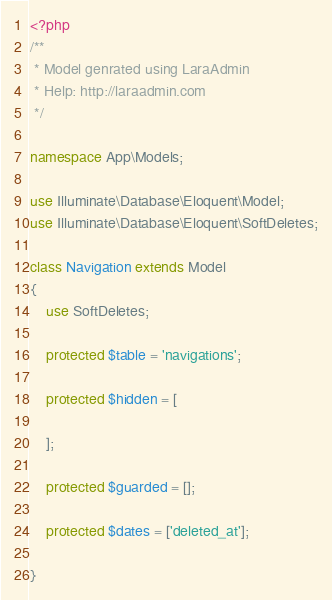<code> <loc_0><loc_0><loc_500><loc_500><_PHP_><?php
/**
 * Model genrated using LaraAdmin
 * Help: http://laraadmin.com
 */

namespace App\Models;

use Illuminate\Database\Eloquent\Model;
use Illuminate\Database\Eloquent\SoftDeletes;

class Navigation extends Model
{
    use SoftDeletes;

	protected $table = 'navigations';

	protected $hidden = [

    ];

	protected $guarded = [];

	protected $dates = ['deleted_at'];

}
</code> 